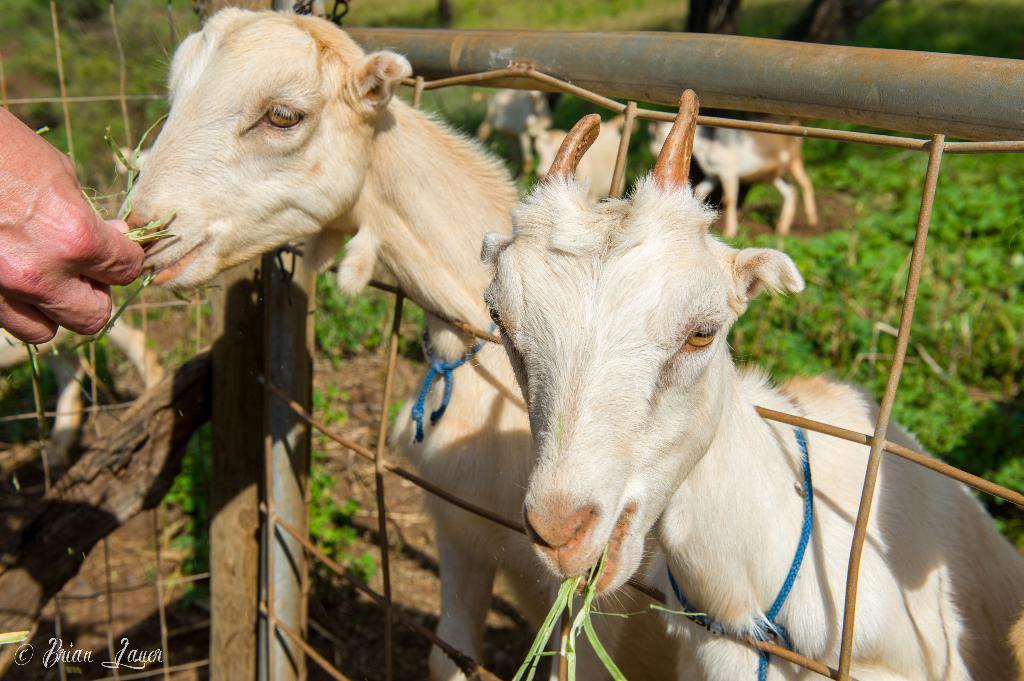Could you give a brief overview of what you see in this image? As we can see in the image there is a person hand, grass, fence and white color goats. 